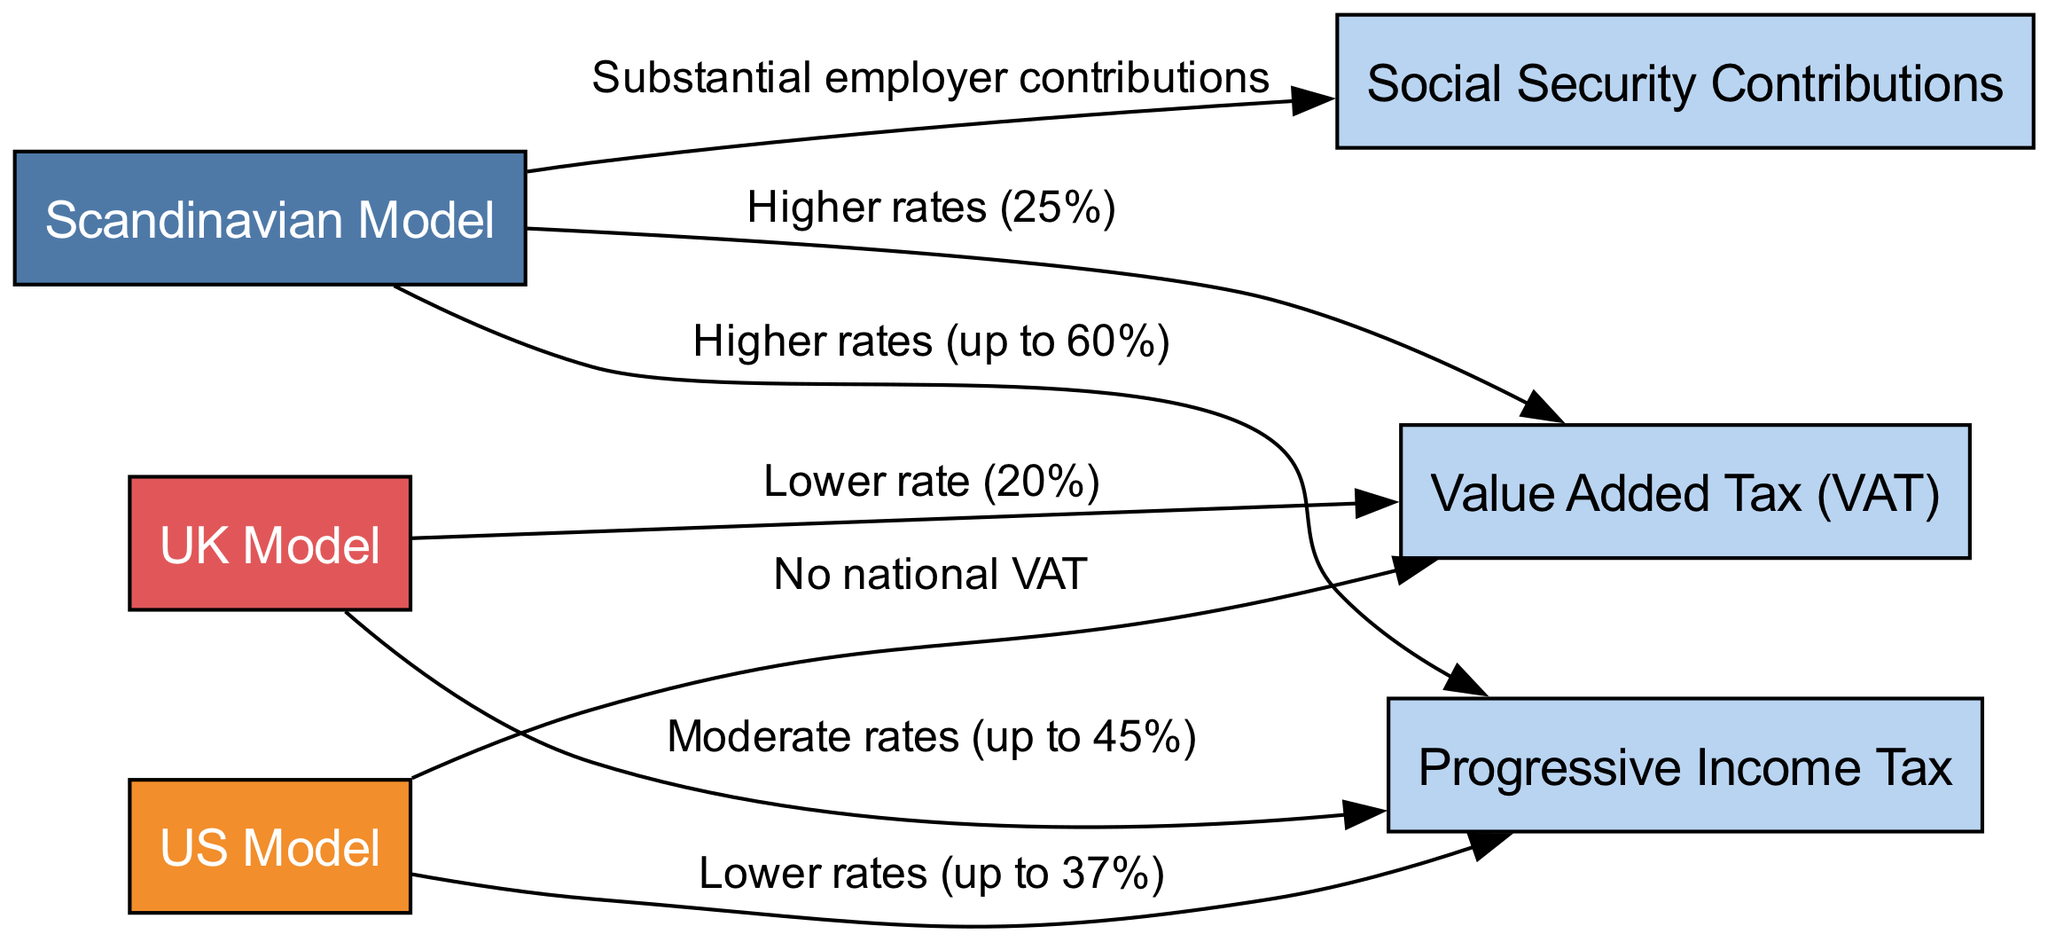What is the highest income tax rate under the Scandinavian model? The diagram shows "Higher rates (up to 60%)" for the Scandinavian Model connected to the Progressive Income Tax node. Therefore, the highest tax rate is indicated as 60%.
Answer: 60% How many different tax systems are represented in the diagram? The diagram includes three models: the Scandinavian Model, US Model, and UK Model. Hence, there are a total of 3 different tax systems represented in the diagram.
Answer: 3 What VAT rate is applied in Scandinavian countries? The diagram links the Scandinavian Model to the Value Added Tax node with the label "Higher rates (25%)". Thus, the VAT rate for Scandinavian countries is stated as 25%.
Answer: 25% Which model has no national VAT? The connection between the US Model and the Value Added Tax node indicates "No national VAT". This makes it clear that the US Model is the one without national VAT.
Answer: US Model What are the employer contributions like in the Scandinavian model? The edge from the Scandinavian Model to the Social Security Contributions node describes them as "Substantial employer contributions". This clearly defines the employer contributions as substantial.
Answer: Substantial How does the income tax rate in the UK Model compare to the Scandinavian model? The UK Model features "Moderate rates (up to 45%)" for the Progressive Income Tax, while the Scandinavian Model has "Higher rates (up to 60%)". This shows that the UK Model has a lower income tax rate compared to the Scandinavian model.
Answer: Lower What is the VAT rate in the UK Model? The diagram indicates a direct link between the UK Model and the Value Added Tax node which states "Lower rate (20%)". Thus, the VAT rate in the UK Model is 20%.
Answer: 20% What type of tax system does the Scandinavian model utilize primarily? The diagram associates the Scandinavian Model with multiple taxes but prominently features the Progressive Income Tax, which is a key component of their tax system. Therefore, it primarily utilizes a progressive tax system.
Answer: Progressive Income Tax How does the US Model's income tax rate compare to that of the Scandinavian model? The comparison shows the US Model having "Lower rates (up to 37%)" for income tax, which is significantly less than the Scandinavian model's "Higher rates (up to 60%)", indicating that the US Model's tax rate is lower.
Answer: Lower 